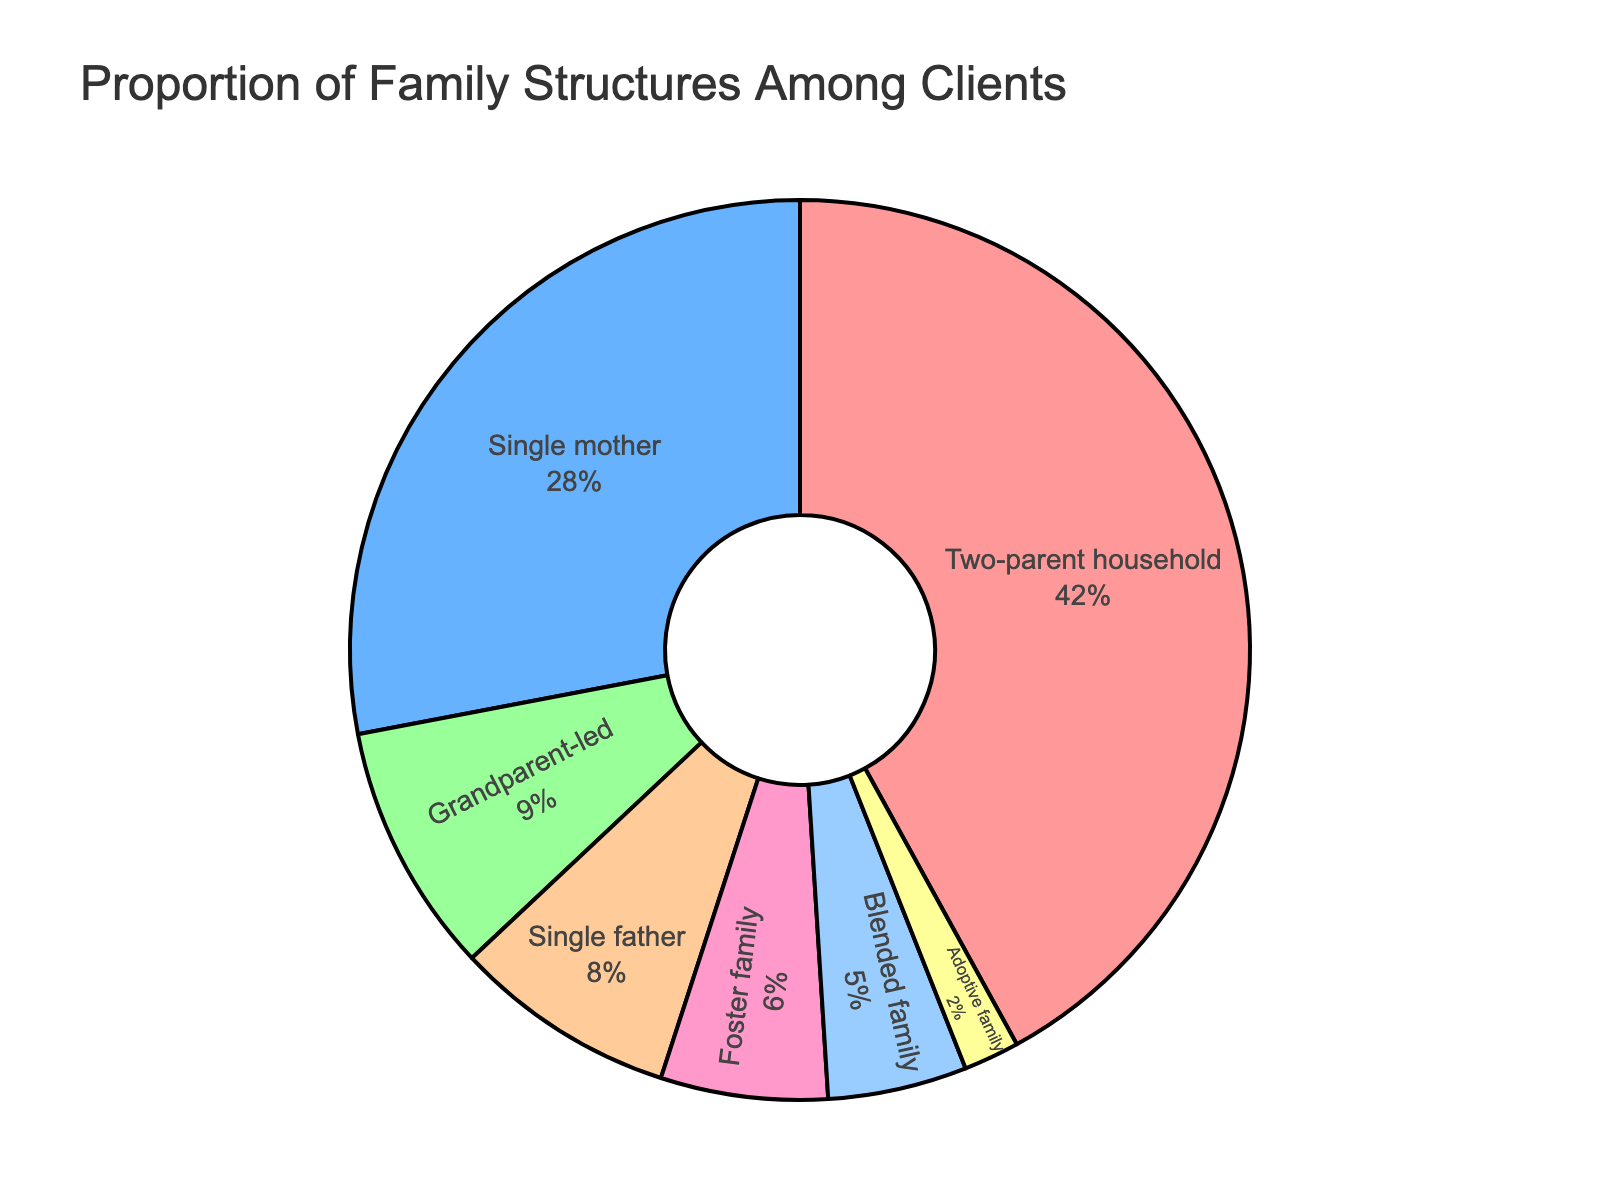What's the combined proportion of single-parent households (single mother and single father)? To find the combined proportion of single-parent households, add the percentages for single mother (28%) and single father (8%). 28 + 8 = 36
Answer: 36 Which family structure has the smallest proportion? Look at the pie chart and identify the segment with the smallest percentage. The smallest proportion is represented by the Adoptive family at 2%.
Answer: Adoptive family What is the difference in percentage between two-parent households and single mother households? Subtract the percentage of single mother households (28%) from the percentage of two-parent households (42%). 42 - 28 = 14
Answer: 14 Which family structures make up more than 10% of the total? Identify the segments in the pie chart that represent more than 10% each. Only the two-parent household (42%) qualifies.
Answer: Two-parent household Are there more grandparent-led households or foster families? Compare the percentages of grandparent-led households (9%) and foster families (6%) from the pie chart. The grandparent-led households have a higher percentage.
Answer: Grandparent-led households What is the average percentage of blended family and adoptive family structures? Add the percentages of blended family (5%) and adoptive family (2%), then divide by 2 to find the average. (5 + 2) / 2 = 3.5
Answer: 3.5 Which family structure is represented by the blue color in the pie chart? Visually inspect the pie chart to see which segment is blue. The blue segment represents the Single mother family structure.
Answer: Single mother What is the combined proportion of blended family and foster family structures? Add the percentages of blended family (5%) and foster family (6%). 5 + 6 = 11
Answer: 11 Which family structure has double the percentage of single father households? Identify the single father percentage (8%) and find which segment is approximately 16%. The grandparent-led household (9%) is not double, but no other category is exactly 16%. So no exact match, the closest is grandparent-led if we think flexibly.
Answer: None 